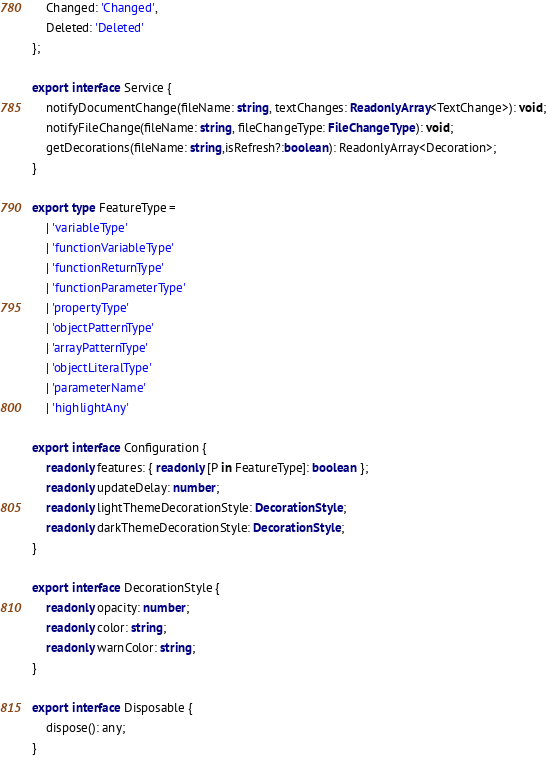Convert code to text. <code><loc_0><loc_0><loc_500><loc_500><_TypeScript_>    Changed: 'Changed',
    Deleted: 'Deleted'
};

export interface Service {
    notifyDocumentChange(fileName: string, textChanges: ReadonlyArray<TextChange>): void;
    notifyFileChange(fileName: string, fileChangeType: FileChangeType): void;
    getDecorations(fileName: string,isRefresh?:boolean): ReadonlyArray<Decoration>;
}

export type FeatureType =
    | 'variableType'
    | 'functionVariableType'
    | 'functionReturnType'
    | 'functionParameterType'
    | 'propertyType'
    | 'objectPatternType'
    | 'arrayPatternType'
    | 'objectLiteralType'
    | 'parameterName'
    | 'highlightAny'

export interface Configuration {
    readonly features: { readonly [P in FeatureType]: boolean };
    readonly updateDelay: number;
    readonly lightThemeDecorationStyle: DecorationStyle;
    readonly darkThemeDecorationStyle: DecorationStyle;
}

export interface DecorationStyle {
    readonly opacity: number;
    readonly color: string;
    readonly warnColor: string;
}

export interface Disposable {
    dispose(): any;
}
</code> 